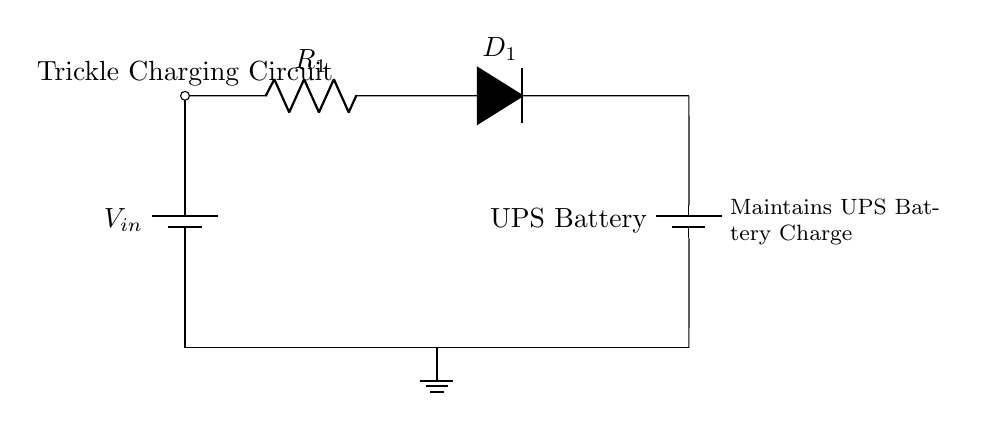What is the type of circuit shown? The circuit is a trickle charging circuit, specifically designed to maintain the charge of a UPS battery. This can be inferred from the label on top of the circuit diagram.
Answer: Trickle charging circuit What does R1 represent in the circuit? R1 represents a resistor in the charging circuit. It is labeled as R1 in the diagram, confirming its role as a resistor.
Answer: Resistor What component is used to prevent reverse current? The component used to prevent reverse current is a diode, labeled as D1 in the circuit diagram. This is a typical function of diodes in charging circuits.
Answer: Diode How many batteries are present in the circuit? There are two batteries in the circuit: one designated as V_in and the other as the UPS battery. The diagram shows both components clearly.
Answer: Two What is the purpose of the trickle charging circuit? The purpose is to maintain the charge of the UPS battery. This is evident from the description next to the UPS battery in the diagram.
Answer: Maintaining charge Describe the voltage source in the circuit. The voltage source is labeled as V_in and is represented as a battery, which provides the required voltage for charging the UPS battery. The label indicates its function clearly.
Answer: Battery 